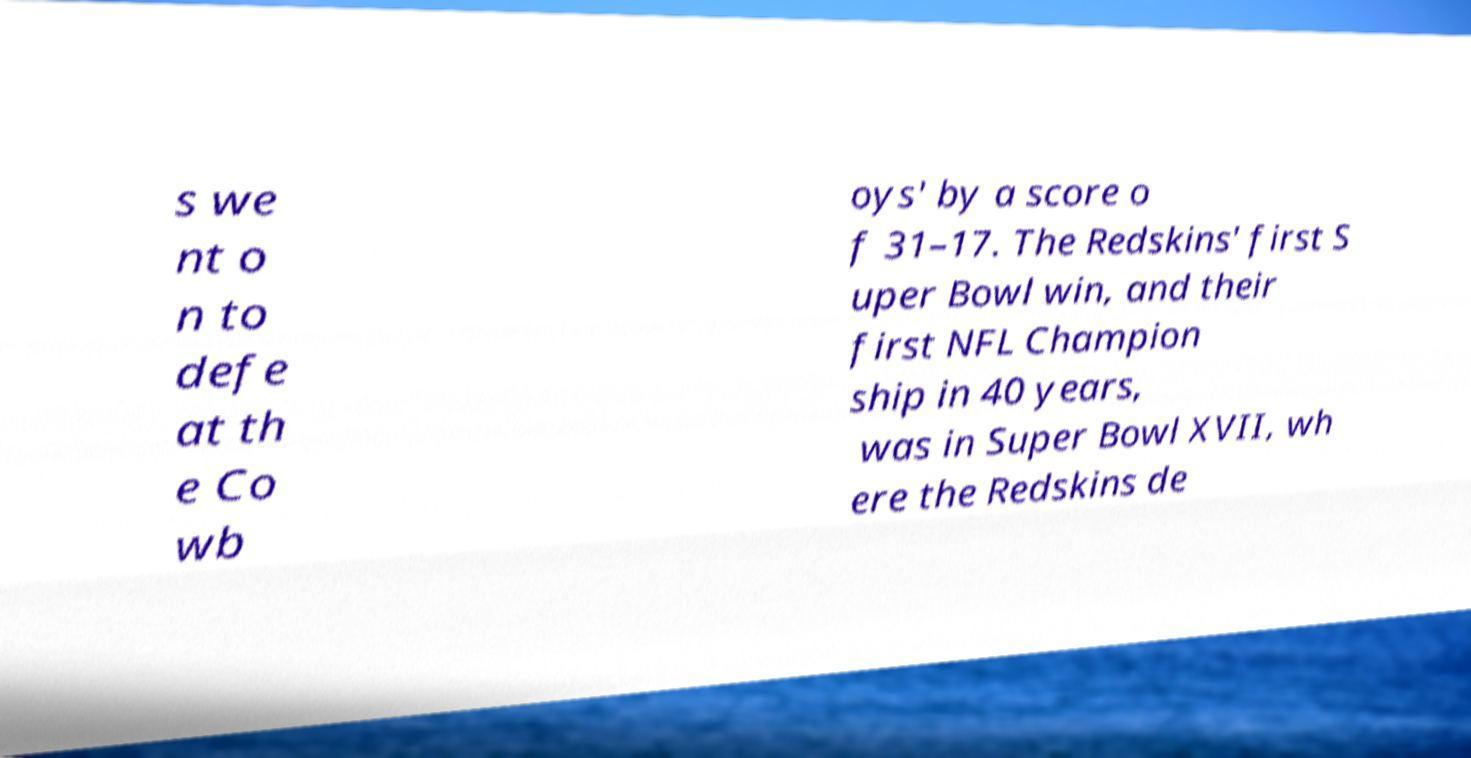There's text embedded in this image that I need extracted. Can you transcribe it verbatim? s we nt o n to defe at th e Co wb oys' by a score o f 31–17. The Redskins' first S uper Bowl win, and their first NFL Champion ship in 40 years, was in Super Bowl XVII, wh ere the Redskins de 